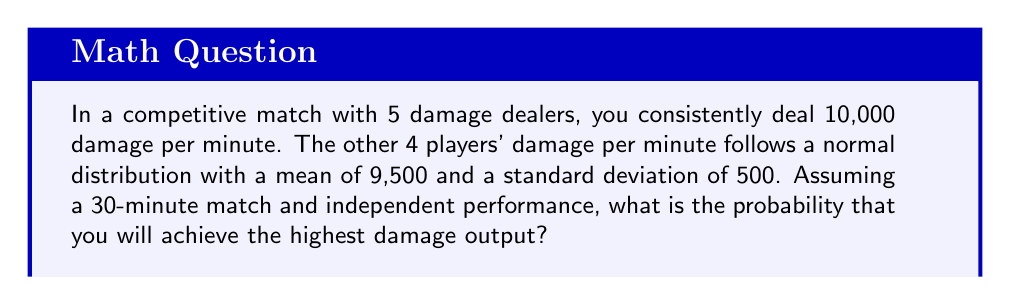Could you help me with this problem? Let's approach this step-by-step:

1) Your total damage over 30 minutes: 
   $30 \times 10,000 = 300,000$

2) For each other player, their damage follows a normal distribution:
   Mean (μ) = $30 \times 9,500 = 285,000$
   Standard deviation (σ) = $\sqrt{30} \times 500 \approx 2,738.6$
   (We multiply by $\sqrt{30}$ because variances add over independent events)

3) The probability that you outscore a single other player is:
   $P(X < 300,000)$ where $X \sim N(285000, 2738.6^2)$

4) We can standardize this:
   $z = \frac{300000 - 285000}{2738.6} \approx 5.48$

5) Using a standard normal table or calculator, we find:
   $P(Z < 5.48) \approx 0.99999979$

6) For you to have the highest damage, you need to outscore all 4 other players. Since their performances are independent:

   $P(\text{highest damage}) = (0.99999979)^4 \approx 0.99999916$
Answer: $0.99999916$ 